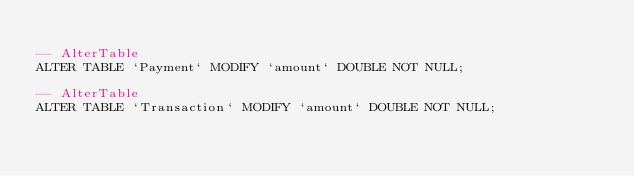Convert code to text. <code><loc_0><loc_0><loc_500><loc_500><_SQL_>
-- AlterTable
ALTER TABLE `Payment` MODIFY `amount` DOUBLE NOT NULL;

-- AlterTable
ALTER TABLE `Transaction` MODIFY `amount` DOUBLE NOT NULL;
</code> 